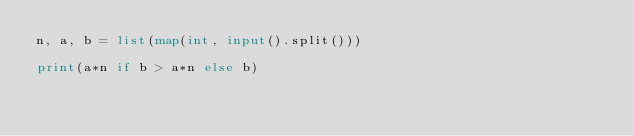<code> <loc_0><loc_0><loc_500><loc_500><_Python_>n, a, b = list(map(int, input().split()))

print(a*n if b > a*n else b)</code> 